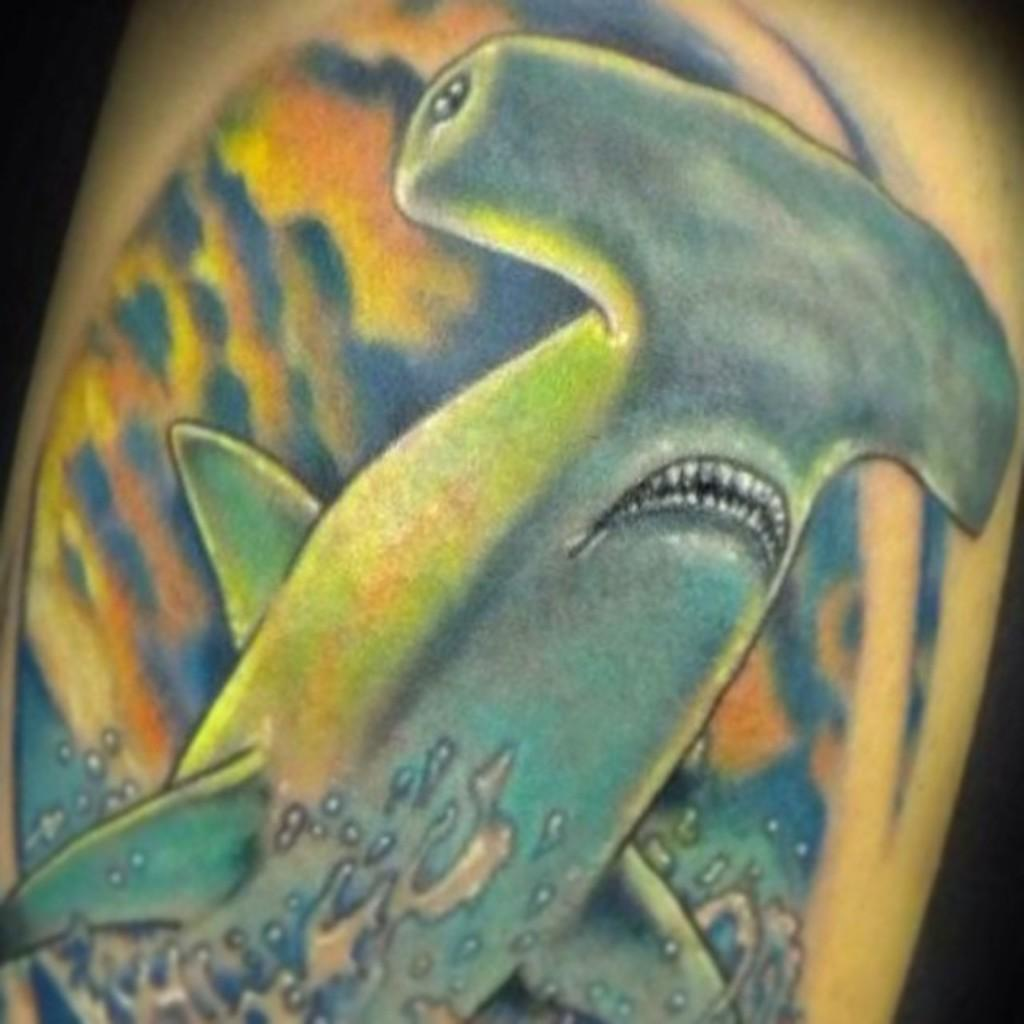What is the main subject of the image? The main subject of the image is a painting. What is depicted in the painting? The painting depicts fish and water. What type of experience can be gained by playing with the fish in the painting? There is no interaction with the fish in the painting, as it is a static image. 